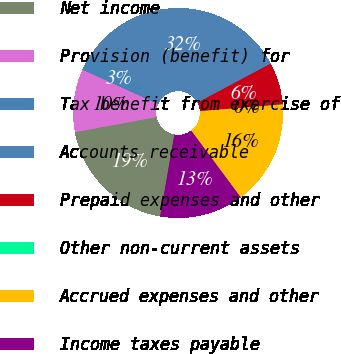Convert chart. <chart><loc_0><loc_0><loc_500><loc_500><pie_chart><fcel>Net income<fcel>Provision (benefit) for<fcel>Tax benefit from exercise of<fcel>Accounts receivable<fcel>Prepaid expenses and other<fcel>Other non-current assets<fcel>Accrued expenses and other<fcel>Income taxes payable<nl><fcel>19.34%<fcel>9.69%<fcel>3.25%<fcel>32.2%<fcel>6.47%<fcel>0.04%<fcel>16.12%<fcel>12.9%<nl></chart> 